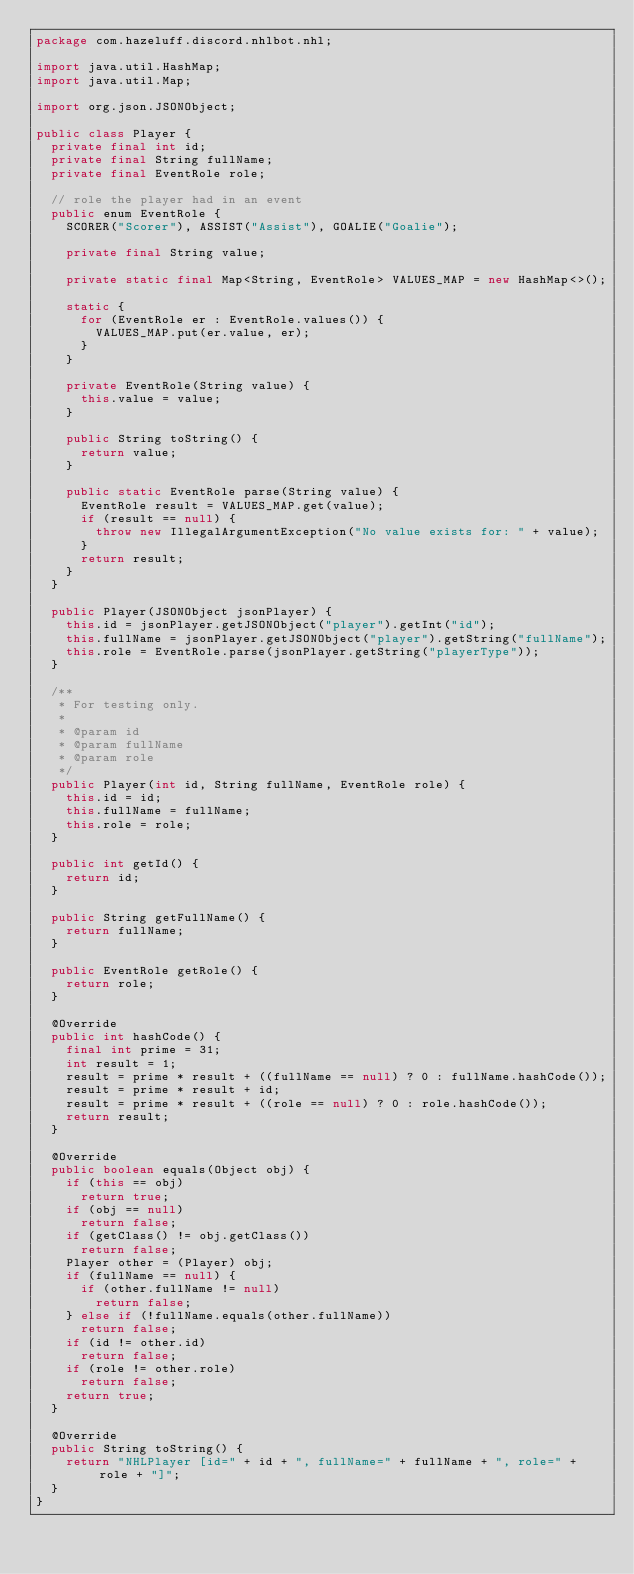<code> <loc_0><loc_0><loc_500><loc_500><_Java_>package com.hazeluff.discord.nhlbot.nhl;

import java.util.HashMap;
import java.util.Map;

import org.json.JSONObject;

public class Player {
	private final int id;
	private final String fullName;
	private final EventRole role;

	// role the player had in an event
	public enum EventRole {
		SCORER("Scorer"), ASSIST("Assist"), GOALIE("Goalie");

		private final String value;

		private static final Map<String, EventRole> VALUES_MAP = new HashMap<>();

		static {
			for (EventRole er : EventRole.values()) {
				VALUES_MAP.put(er.value, er);
			}
		}

		private EventRole(String value) {
			this.value = value;
		}

		public String toString() {
			return value;
		}

		public static EventRole parse(String value) {
			EventRole result = VALUES_MAP.get(value);
			if (result == null) {
				throw new IllegalArgumentException("No value exists for: " + value);
			}
			return result;
		}
	}

	public Player(JSONObject jsonPlayer) {
		this.id = jsonPlayer.getJSONObject("player").getInt("id");
		this.fullName = jsonPlayer.getJSONObject("player").getString("fullName");
		this.role = EventRole.parse(jsonPlayer.getString("playerType"));
	}

	/**
	 * For testing only.
	 * 
	 * @param id
	 * @param fullName
	 * @param role
	 */
	public Player(int id, String fullName, EventRole role) {
		this.id = id;
		this.fullName = fullName;
		this.role = role;
	}

	public int getId() {
		return id;
	}

	public String getFullName() {
		return fullName;
	}

	public EventRole getRole() {
		return role;
	}

	@Override
	public int hashCode() {
		final int prime = 31;
		int result = 1;
		result = prime * result + ((fullName == null) ? 0 : fullName.hashCode());
		result = prime * result + id;
		result = prime * result + ((role == null) ? 0 : role.hashCode());
		return result;
	}

	@Override
	public boolean equals(Object obj) {
		if (this == obj)
			return true;
		if (obj == null)
			return false;
		if (getClass() != obj.getClass())
			return false;
		Player other = (Player) obj;
		if (fullName == null) {
			if (other.fullName != null)
				return false;
		} else if (!fullName.equals(other.fullName))
			return false;
		if (id != other.id)
			return false;
		if (role != other.role)
			return false;
		return true;
	}

	@Override
	public String toString() {
		return "NHLPlayer [id=" + id + ", fullName=" + fullName + ", role=" + role + "]";
	}
}
</code> 